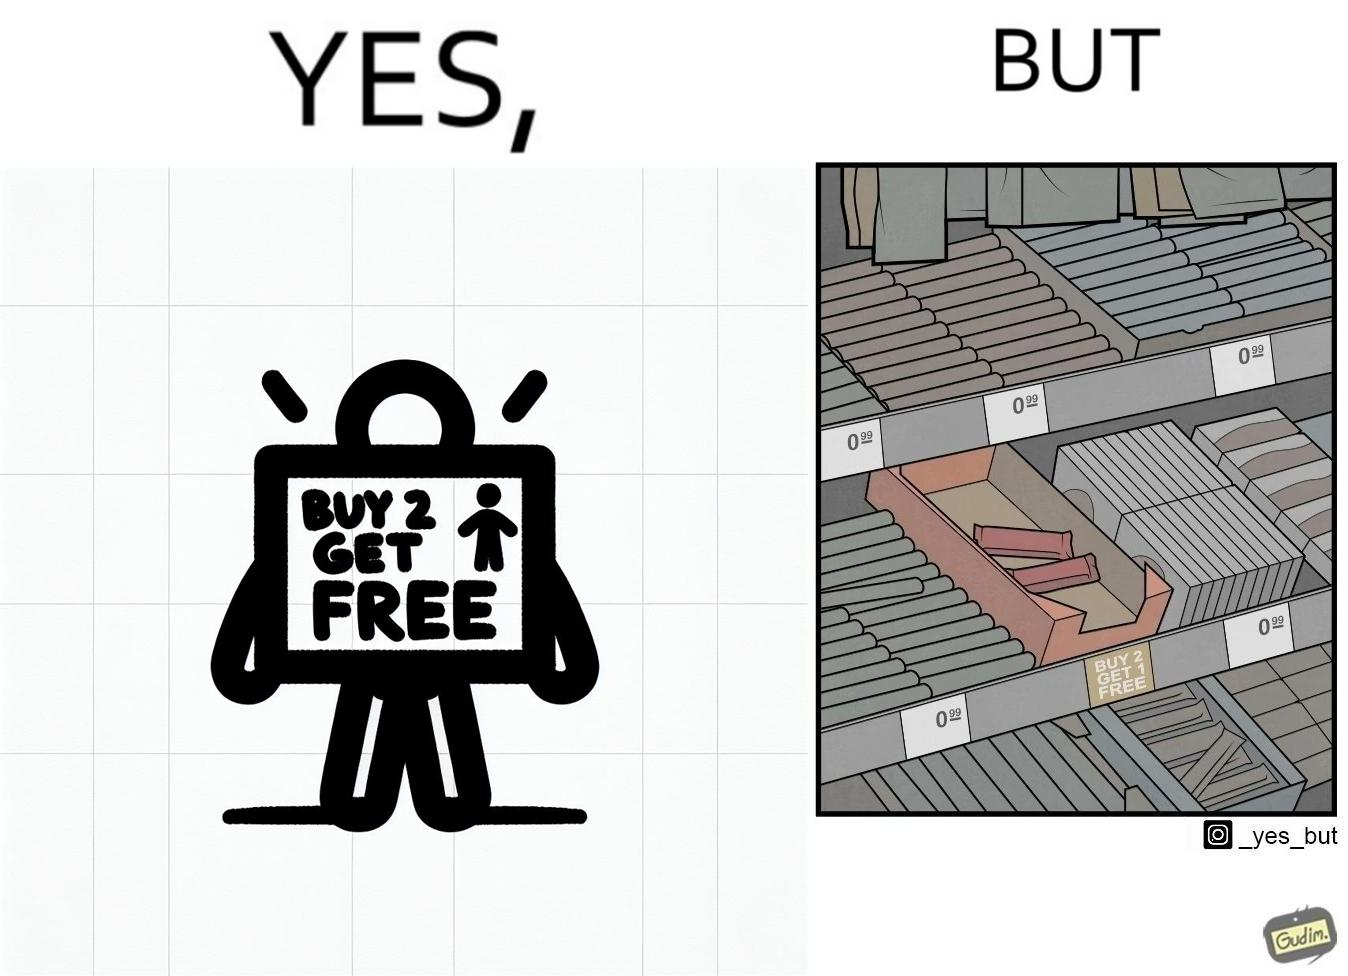Describe the satirical element in this image. The image is funny because while there is an offer that lets the buyer have a free item if they buy two items of the product, there is only two units left which means that the buyer won't get the free unit. 